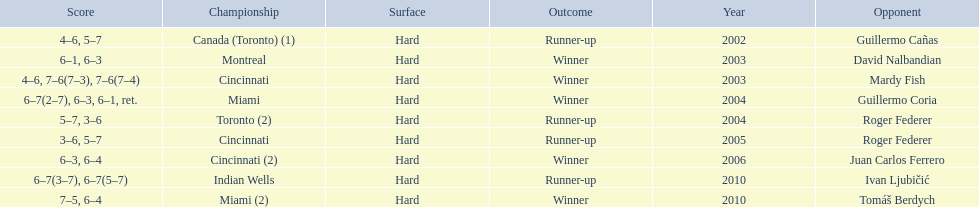How many times has he been runner-up? 4. 